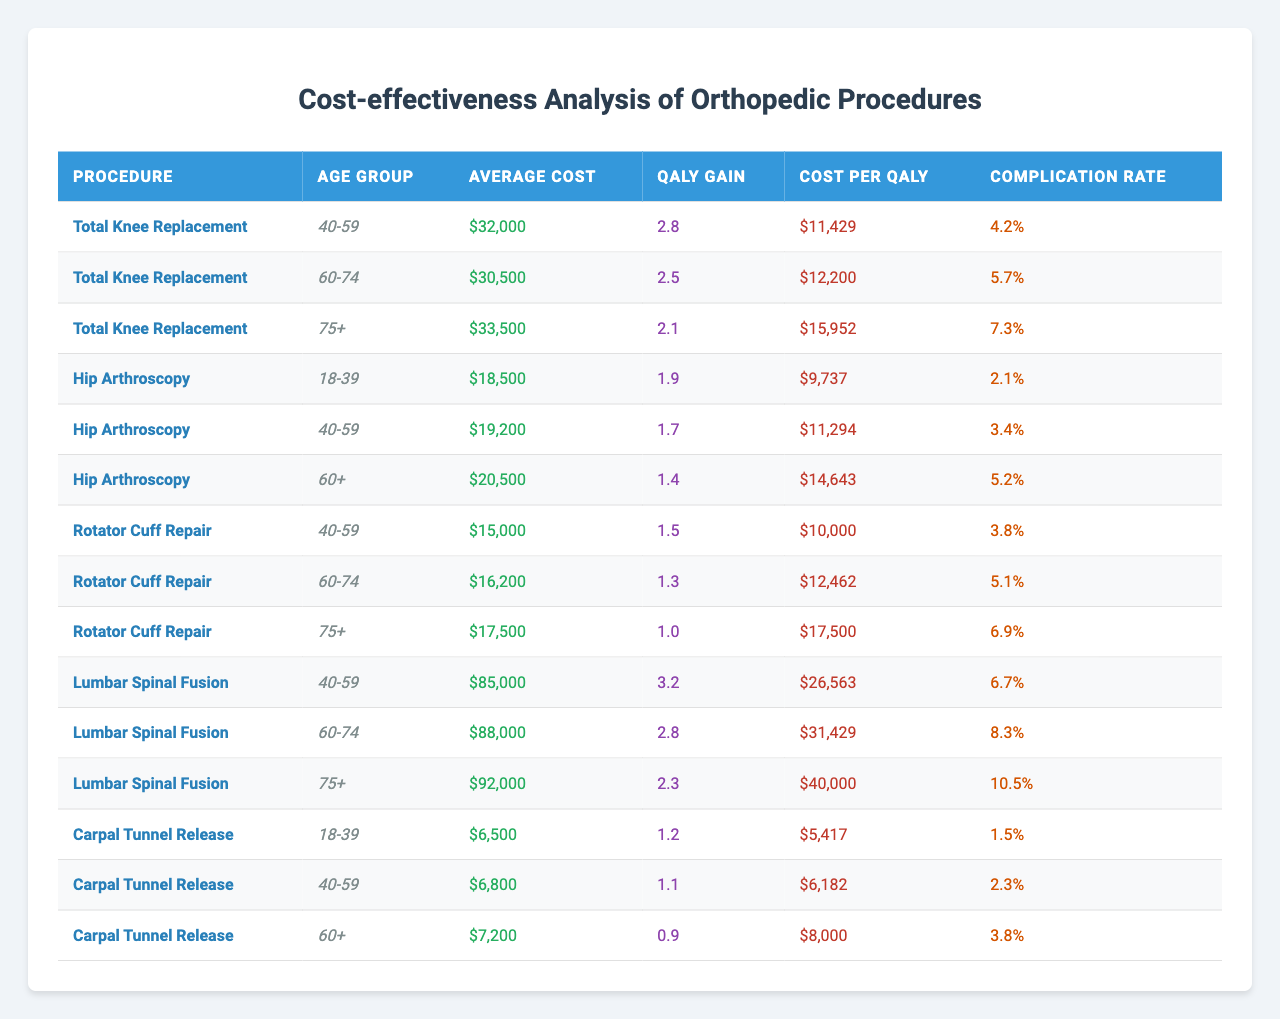What is the average cost of Total Knee Replacement for the 60-74 age group? Referring to the table, the average cost of Total Knee Replacement for the 60-74 age group is listed as $30,500.
Answer: $30,500 What is the QALY gain for the Hip Arthroscopy procedure in the 18-39 age group? The table shows that the QALY gain for the Hip Arthroscopy procedure in the 18-39 age group is 1.9.
Answer: 1.9 Which age group for Lumbar Spinal Fusion has the highest cost per QALY? Looking at the Cost per QALY values for Lumbar Spinal Fusion, the 75+ age group shows a Cost per QALY of $40,000, which is higher than the other age groups (40-59 at $26,563 and 60-74 at $31,429).
Answer: 75+ What is the complication rate for Rotator Cuff Repair in the 60-74 age group? The complication rate for Rotator Cuff Repair in the 60-74 age group is given as 5.1%.
Answer: 5.1% Which procedure has the lowest average cost across all age groups? By examining the average costs for each procedure, Carpal Tunnel Release has the lowest average cost ($6,500 for 18-39, $6,800 for 40-59, and $7,200 for 60+), compared to other procedures.
Answer: Carpal Tunnel Release What is the average QALY gain for the Total Knee Replacement procedure across all age groups? To find the average QALY gain for Total Knee Replacement, we sum the QALY gains (2.8 + 2.5 + 2.1 = 7.4) and divide by the number of age groups (3), resulting in an average of 7.4 / 3 = 2.47.
Answer: 2.47 Is the average cost of Hip Arthroscopy higher for the 60+ age group compared to the 40-59 age group? The average cost of Hip Arthroscopy for the 60+ age group is $20,500, while for the 40-59 age group it is $19,200; hence, it is indeed higher for the 60+ age group.
Answer: Yes What is the difference in complication rates between Hip Arthroscopy for the 18-39 age group and Lumbar Spinal Fusion for the 60-74 age group? The complication rate for Hip Arthroscopy in the 18-39 age group is 2.1%, and for Lumbar Spinal Fusion in the 60-74 age group it is 8.3%. The difference is calculated as 8.3% - 2.1% = 6.2%.
Answer: 6.2% Among all procedures, which one offers the least QALY gain for the 75+ age group? Reviewing the QALY gains of all procedures for the 75+ age group, Rotator Cuff Repair shows the lowest QALY gain at 1.0 when compared to the Total Knee Replacement (2.1) and Lumbar Spinal Fusion (2.3).
Answer: Rotator Cuff Repair What is the total average cost of all procedures for the age group 40-59? To determine the total average cost for the age group 40-59, we will add the average costs: Total Knee Replacement ($32,000) + Hip Arthroscopy ($19,200) + Rotator Cuff Repair ($15,000) + Lumbar Spinal Fusion ($85,000) + Carpal Tunnel Release ($6,800) = $158,000. The average across all procedures is then 158,000/5 = $31,600.
Answer: $31,600 